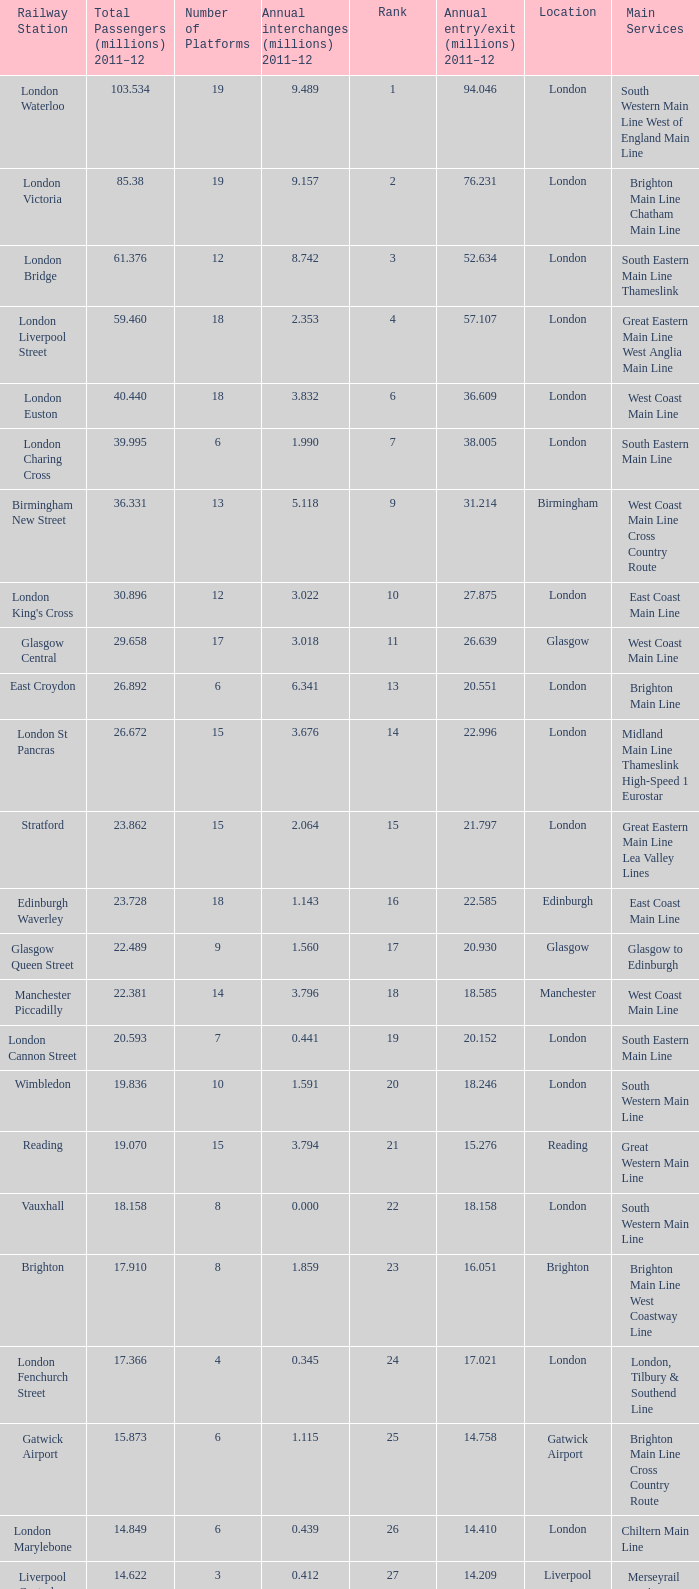What is the lowest rank of Gatwick Airport?  25.0. Could you help me parse every detail presented in this table? {'header': ['Railway Station', 'Total Passengers (millions) 2011–12', 'Number of Platforms', 'Annual interchanges (millions) 2011–12', 'Rank', 'Annual entry/exit (millions) 2011–12', 'Location', 'Main Services'], 'rows': [['London Waterloo', '103.534', '19', '9.489', '1', '94.046', 'London', 'South Western Main Line West of England Main Line'], ['London Victoria', '85.38', '19', '9.157', '2', '76.231', 'London', 'Brighton Main Line Chatham Main Line'], ['London Bridge', '61.376', '12', '8.742', '3', '52.634', 'London', 'South Eastern Main Line Thameslink'], ['London Liverpool Street', '59.460', '18', '2.353', '4', '57.107', 'London', 'Great Eastern Main Line West Anglia Main Line'], ['London Euston', '40.440', '18', '3.832', '6', '36.609', 'London', 'West Coast Main Line'], ['London Charing Cross', '39.995', '6', '1.990', '7', '38.005', 'London', 'South Eastern Main Line'], ['Birmingham New Street', '36.331', '13', '5.118', '9', '31.214', 'Birmingham', 'West Coast Main Line Cross Country Route'], ["London King's Cross", '30.896', '12', '3.022', '10', '27.875', 'London', 'East Coast Main Line'], ['Glasgow Central', '29.658', '17', '3.018', '11', '26.639', 'Glasgow', 'West Coast Main Line'], ['East Croydon', '26.892', '6', '6.341', '13', '20.551', 'London', 'Brighton Main Line'], ['London St Pancras', '26.672', '15', '3.676', '14', '22.996', 'London', 'Midland Main Line Thameslink High-Speed 1 Eurostar'], ['Stratford', '23.862', '15', '2.064', '15', '21.797', 'London', 'Great Eastern Main Line Lea Valley Lines'], ['Edinburgh Waverley', '23.728', '18', '1.143', '16', '22.585', 'Edinburgh', 'East Coast Main Line'], ['Glasgow Queen Street', '22.489', '9', '1.560', '17', '20.930', 'Glasgow', 'Glasgow to Edinburgh'], ['Manchester Piccadilly', '22.381', '14', '3.796', '18', '18.585', 'Manchester', 'West Coast Main Line'], ['London Cannon Street', '20.593', '7', '0.441', '19', '20.152', 'London', 'South Eastern Main Line'], ['Wimbledon', '19.836', '10', '1.591', '20', '18.246', 'London', 'South Western Main Line'], ['Reading', '19.070', '15', '3.794', '21', '15.276', 'Reading', 'Great Western Main Line'], ['Vauxhall', '18.158', '8', '0.000', '22', '18.158', 'London', 'South Western Main Line'], ['Brighton', '17.910', '8', '1.859', '23', '16.051', 'Brighton', 'Brighton Main Line West Coastway Line'], ['London Fenchurch Street', '17.366', '4', '0.345', '24', '17.021', 'London', 'London, Tilbury & Southend Line'], ['Gatwick Airport', '15.873', '6', '1.115', '25', '14.758', 'Gatwick Airport', 'Brighton Main Line Cross Country Route'], ['London Marylebone', '14.849', '6', '0.439', '26', '14.410', 'London', 'Chiltern Main Line'], ['Liverpool Central', '14.622', '3', '0.412', '27', '14.209', 'Liverpool', 'Merseyrail services (Wirral and Northern lines)'], ['Liverpool Lime Street', '14.613', '10', '0.778', '28', '13.835', 'Liverpool', 'West Coast Main Line Liverpool to Manchester Lines'], ['London Blackfriars', '13.850', '4', '1.059', '29', '12.79', 'London', 'Thameslink']]} 